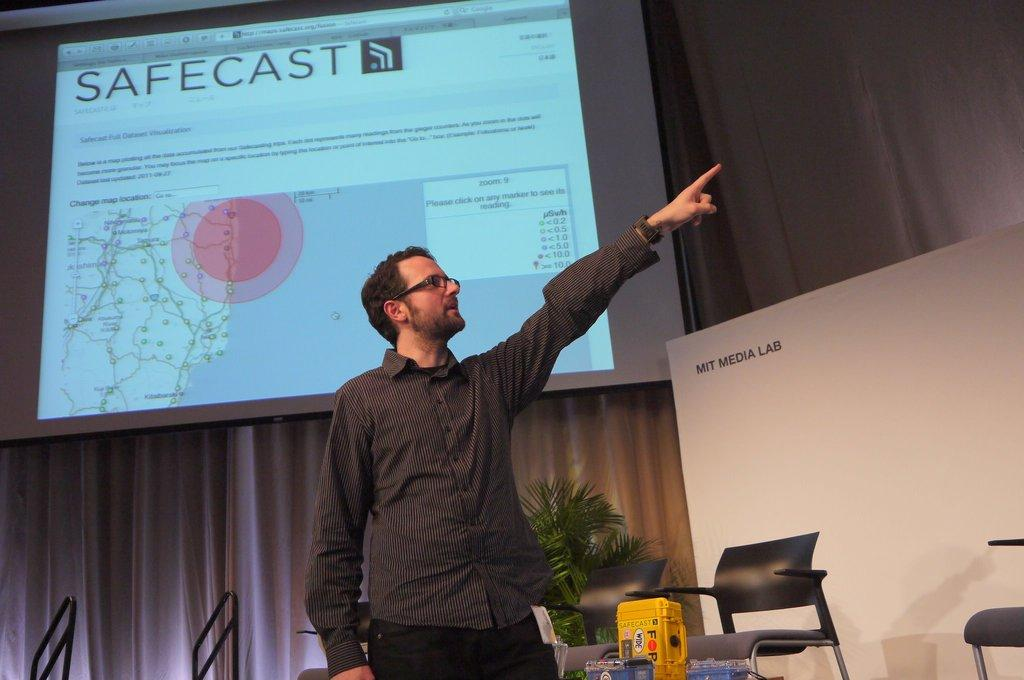Who is the person in the image? There is a man in the image. What is the man doing in the image? The man is standing and pointing his hands towards the left side. What can be seen behind the man in the image? There is a projected image behind the man. What color is the thread used to create the man's clothing in the image? There is no thread visible in the image, and the man's clothing is not described in the provided facts. 